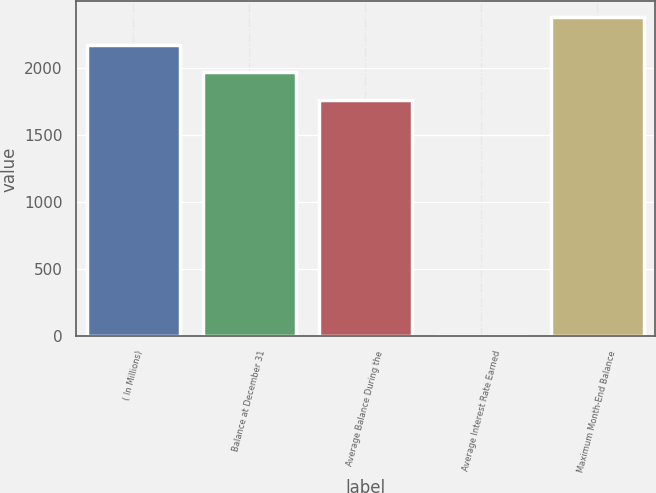<chart> <loc_0><loc_0><loc_500><loc_500><bar_chart><fcel>( In Millions)<fcel>Balance at December 31<fcel>Average Balance During the<fcel>Average Interest Rate Earned<fcel>Maximum Month-End Balance<nl><fcel>2174.08<fcel>1969.09<fcel>1764.1<fcel>1.04<fcel>2379.07<nl></chart> 